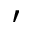<formula> <loc_0><loc_0><loc_500><loc_500>^ { \prime }</formula> 